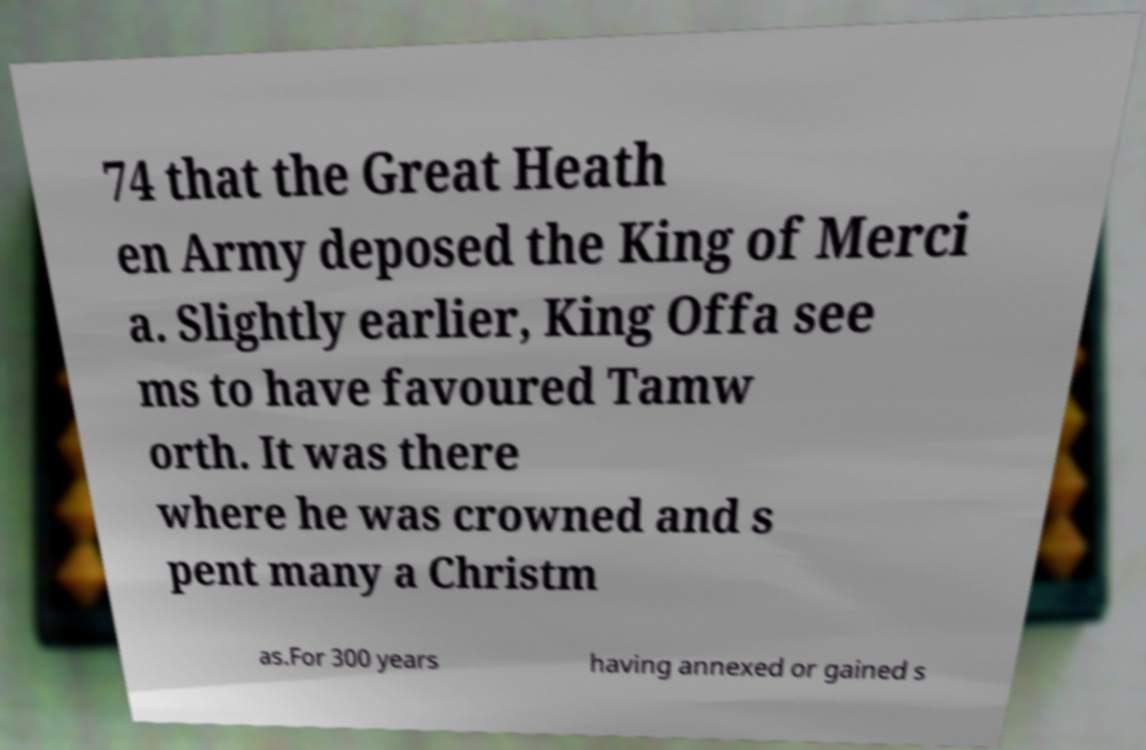What messages or text are displayed in this image? I need them in a readable, typed format. 74 that the Great Heath en Army deposed the King of Merci a. Slightly earlier, King Offa see ms to have favoured Tamw orth. It was there where he was crowned and s pent many a Christm as.For 300 years having annexed or gained s 